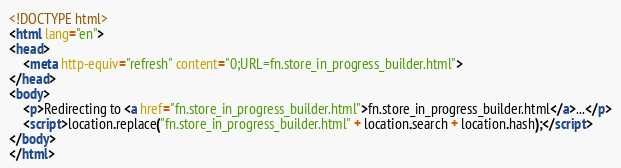Convert code to text. <code><loc_0><loc_0><loc_500><loc_500><_HTML_><!DOCTYPE html>
<html lang="en">
<head>
    <meta http-equiv="refresh" content="0;URL=fn.store_in_progress_builder.html">
</head>
<body>
    <p>Redirecting to <a href="fn.store_in_progress_builder.html">fn.store_in_progress_builder.html</a>...</p>
    <script>location.replace("fn.store_in_progress_builder.html" + location.search + location.hash);</script>
</body>
</html></code> 